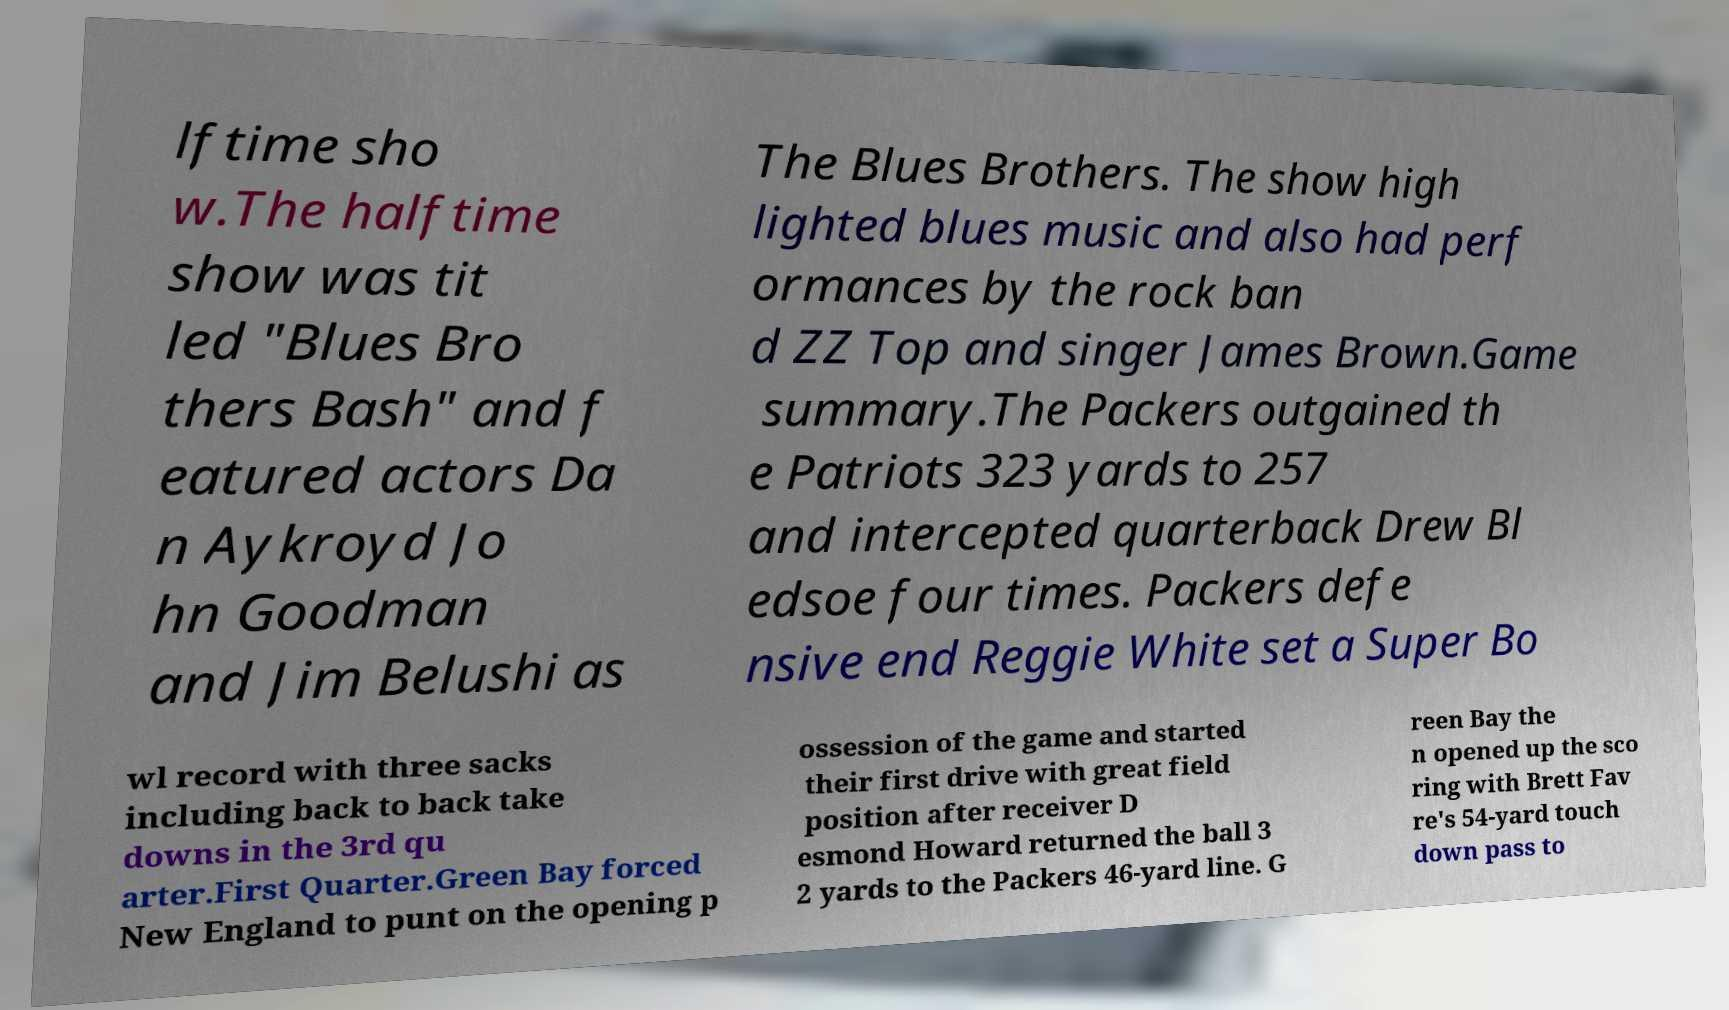Can you accurately transcribe the text from the provided image for me? lftime sho w.The halftime show was tit led "Blues Bro thers Bash" and f eatured actors Da n Aykroyd Jo hn Goodman and Jim Belushi as The Blues Brothers. The show high lighted blues music and also had perf ormances by the rock ban d ZZ Top and singer James Brown.Game summary.The Packers outgained th e Patriots 323 yards to 257 and intercepted quarterback Drew Bl edsoe four times. Packers defe nsive end Reggie White set a Super Bo wl record with three sacks including back to back take downs in the 3rd qu arter.First Quarter.Green Bay forced New England to punt on the opening p ossession of the game and started their first drive with great field position after receiver D esmond Howard returned the ball 3 2 yards to the Packers 46-yard line. G reen Bay the n opened up the sco ring with Brett Fav re's 54-yard touch down pass to 